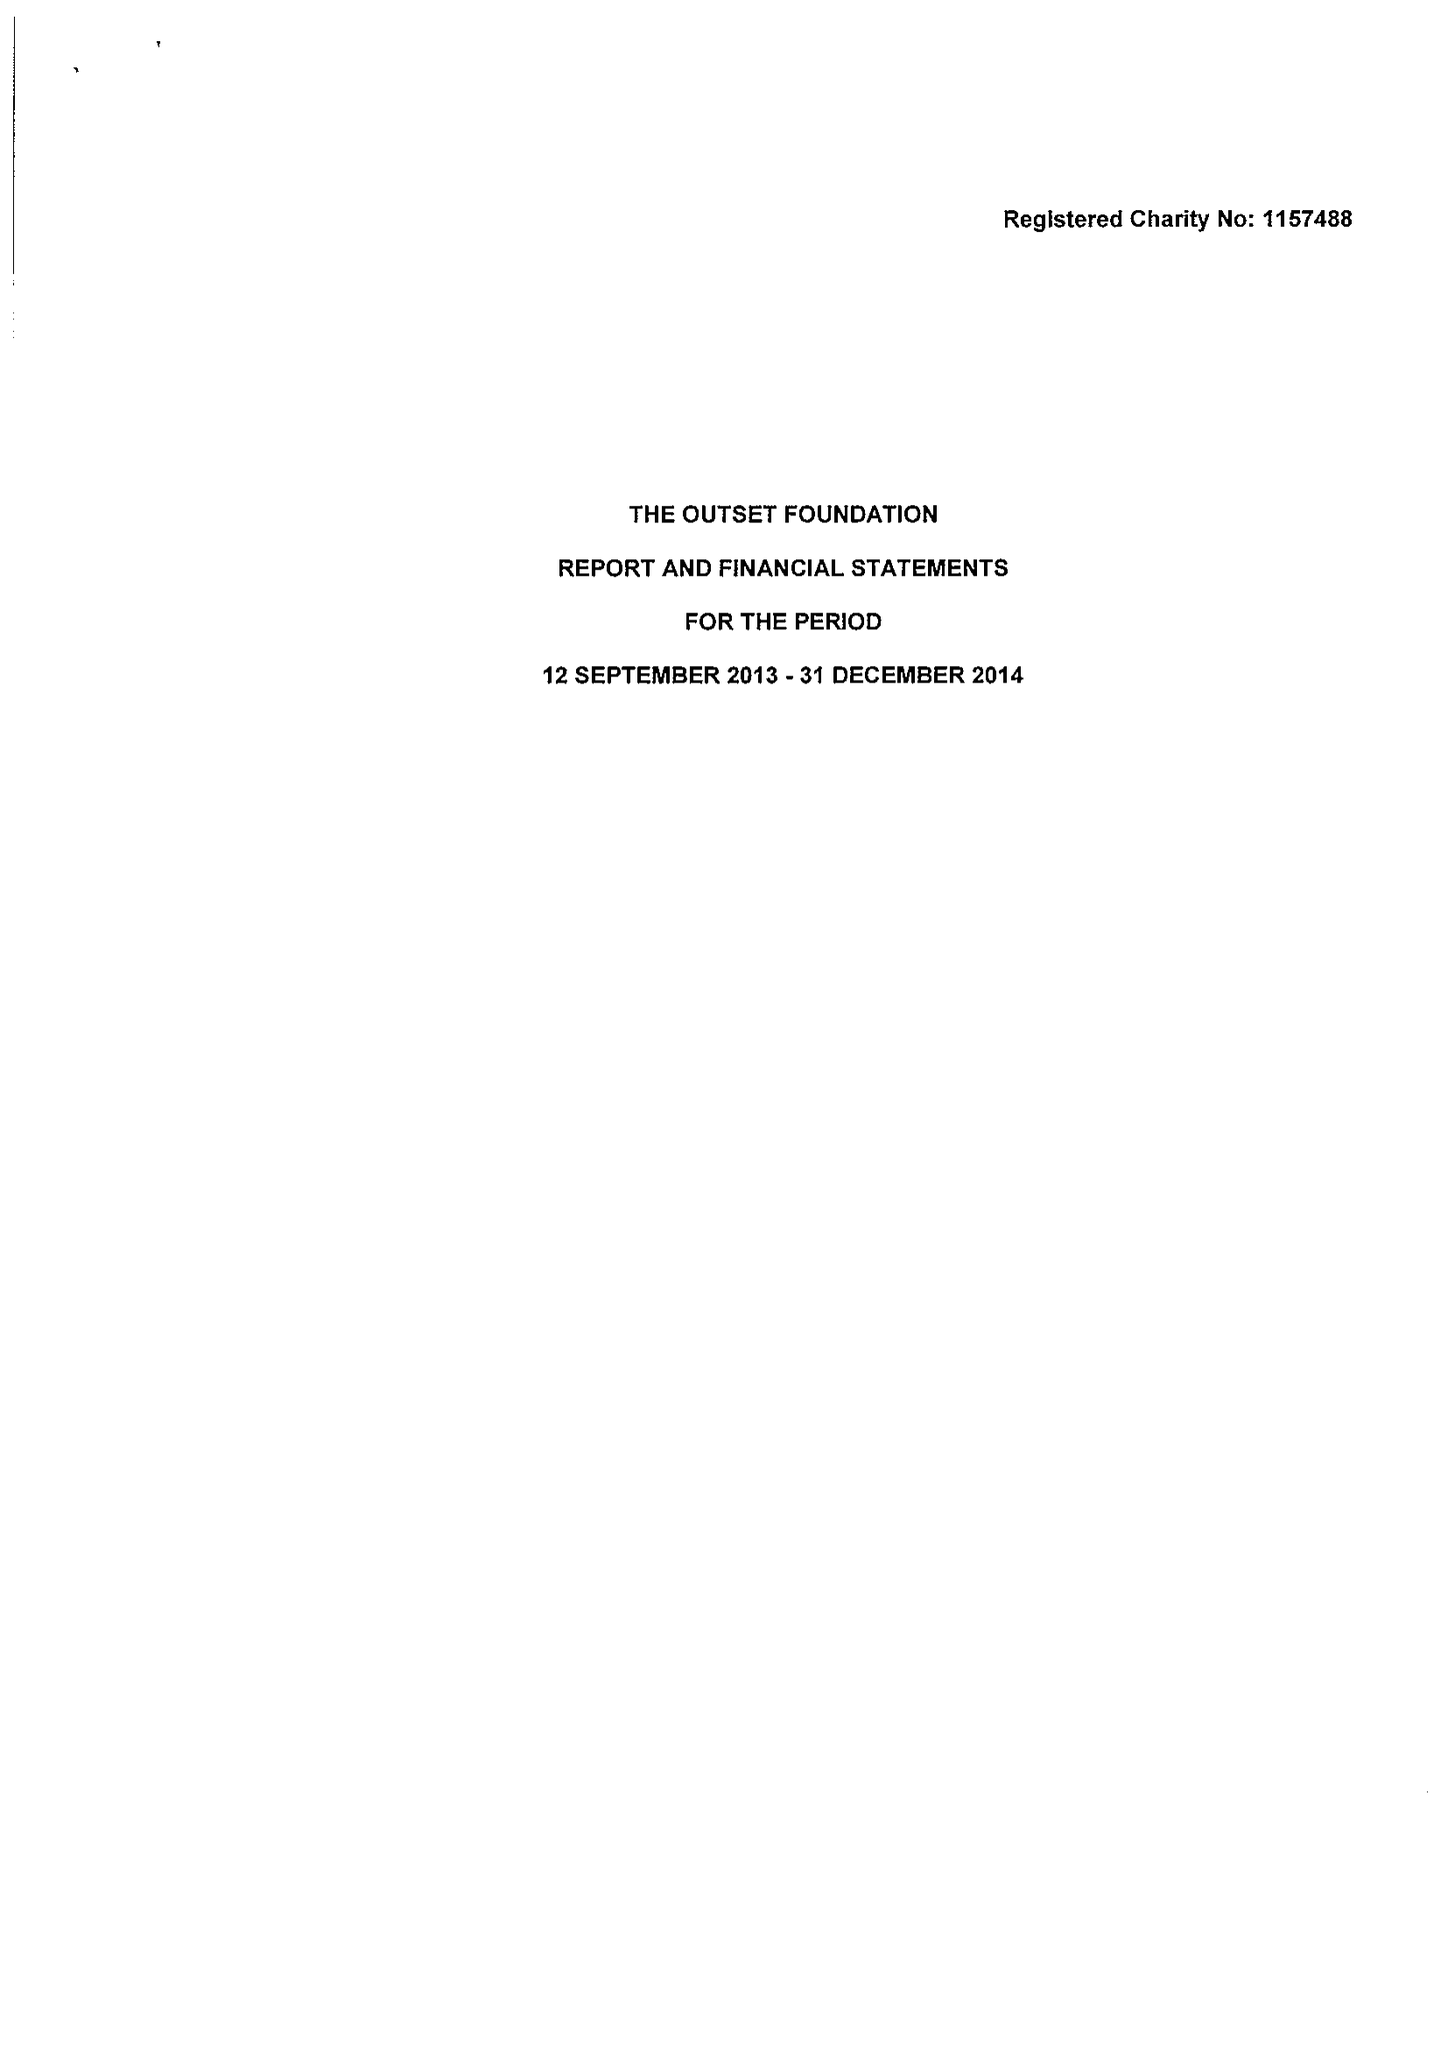What is the value for the charity_number?
Answer the question using a single word or phrase. 1157488 